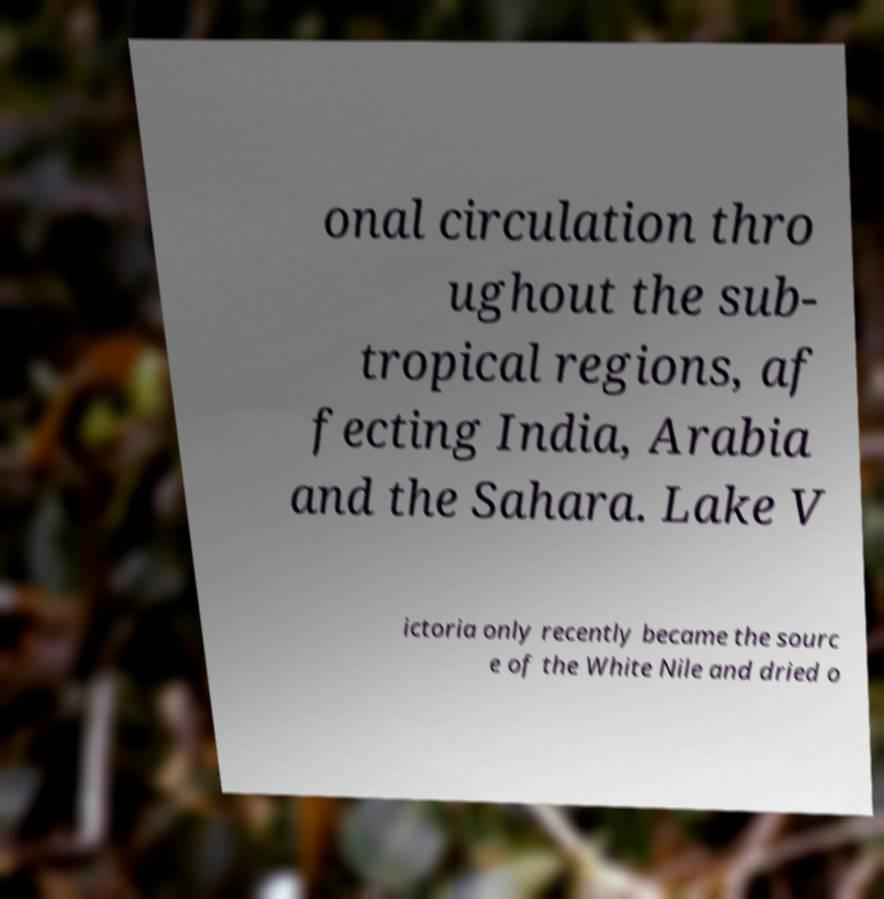I need the written content from this picture converted into text. Can you do that? onal circulation thro ughout the sub- tropical regions, af fecting India, Arabia and the Sahara. Lake V ictoria only recently became the sourc e of the White Nile and dried o 